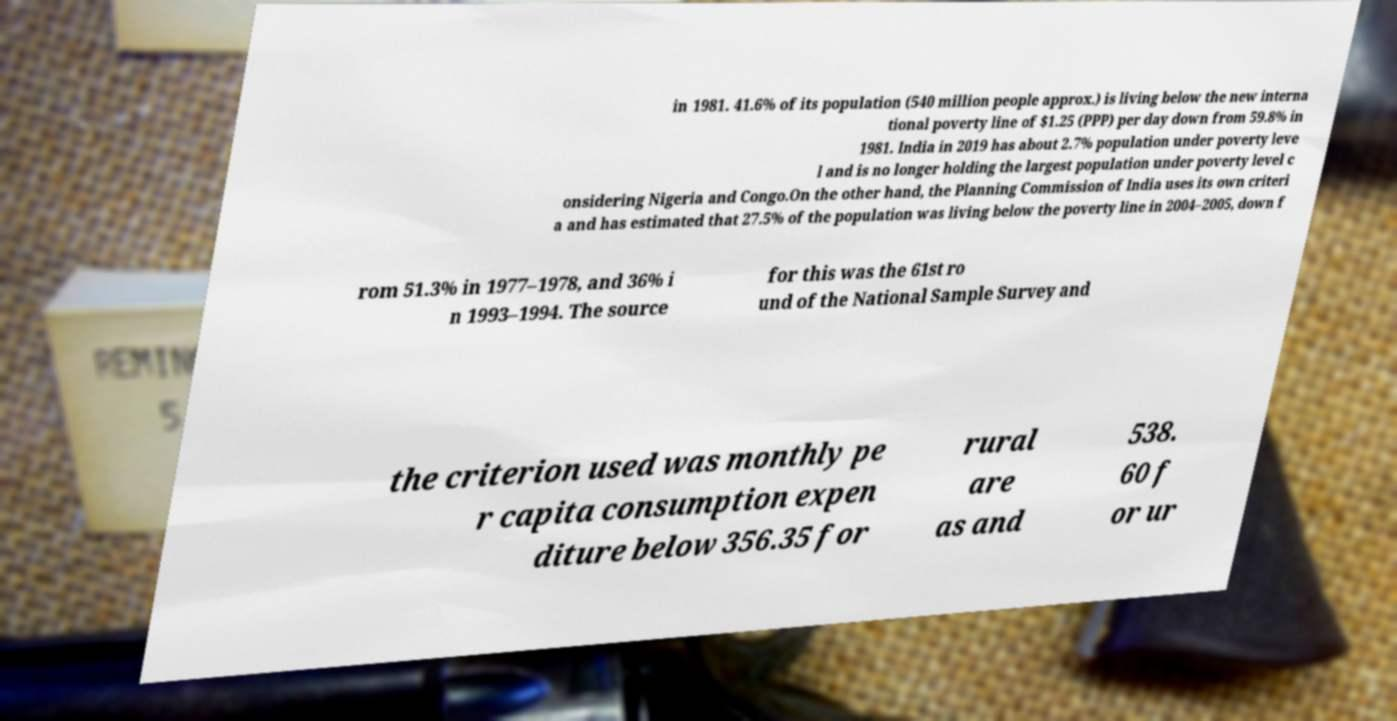For documentation purposes, I need the text within this image transcribed. Could you provide that? in 1981. 41.6% of its population (540 million people approx.) is living below the new interna tional poverty line of $1.25 (PPP) per day down from 59.8% in 1981. India in 2019 has about 2.7% population under poverty leve l and is no longer holding the largest population under poverty level c onsidering Nigeria and Congo.On the other hand, the Planning Commission of India uses its own criteri a and has estimated that 27.5% of the population was living below the poverty line in 2004–2005, down f rom 51.3% in 1977–1978, and 36% i n 1993–1994. The source for this was the 61st ro und of the National Sample Survey and the criterion used was monthly pe r capita consumption expen diture below 356.35 for rural are as and 538. 60 f or ur 